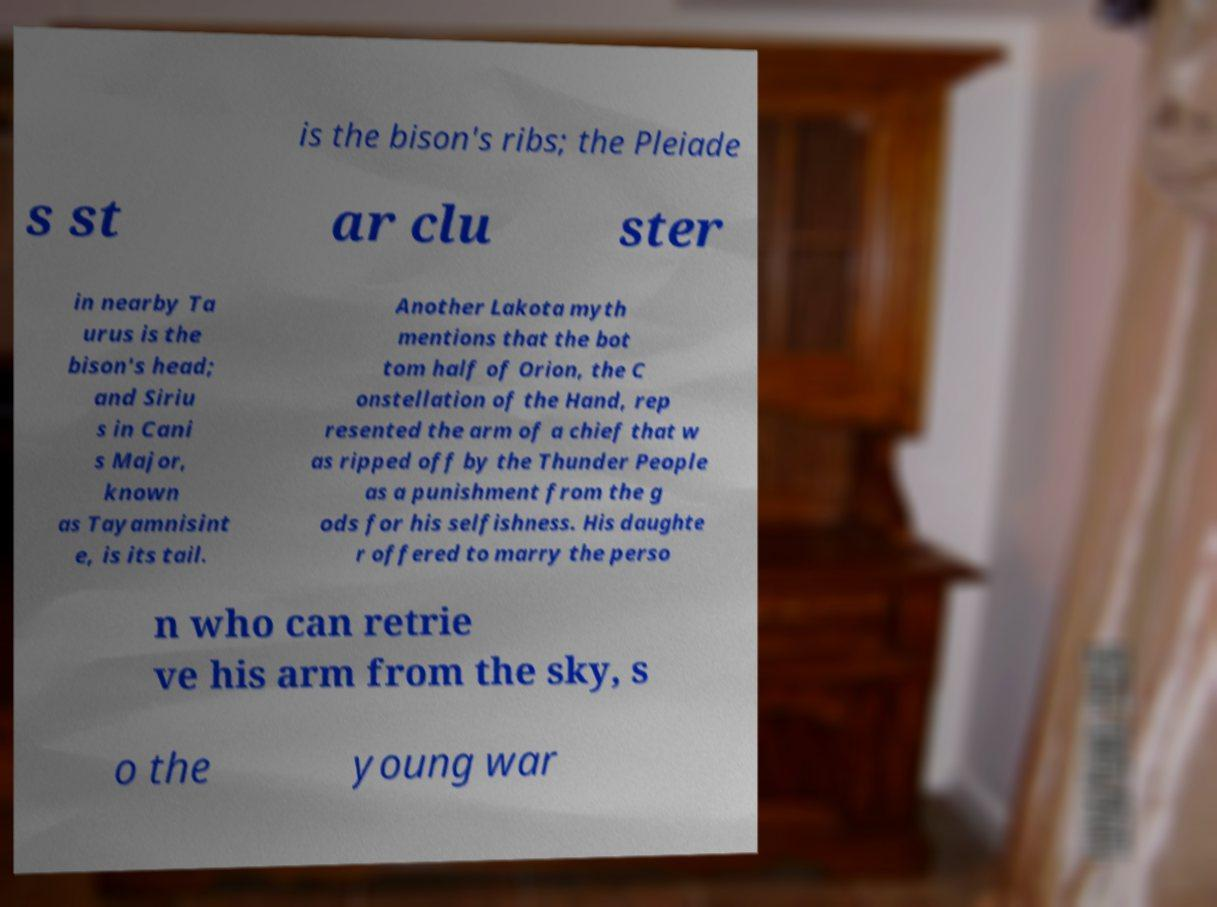Could you assist in decoding the text presented in this image and type it out clearly? is the bison's ribs; the Pleiade s st ar clu ster in nearby Ta urus is the bison's head; and Siriu s in Cani s Major, known as Tayamnisint e, is its tail. Another Lakota myth mentions that the bot tom half of Orion, the C onstellation of the Hand, rep resented the arm of a chief that w as ripped off by the Thunder People as a punishment from the g ods for his selfishness. His daughte r offered to marry the perso n who can retrie ve his arm from the sky, s o the young war 